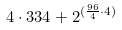<formula> <loc_0><loc_0><loc_500><loc_500>4 \cdot 3 3 4 + 2 ^ { ( \frac { 9 6 } { 4 } \cdot 4 ) }</formula> 